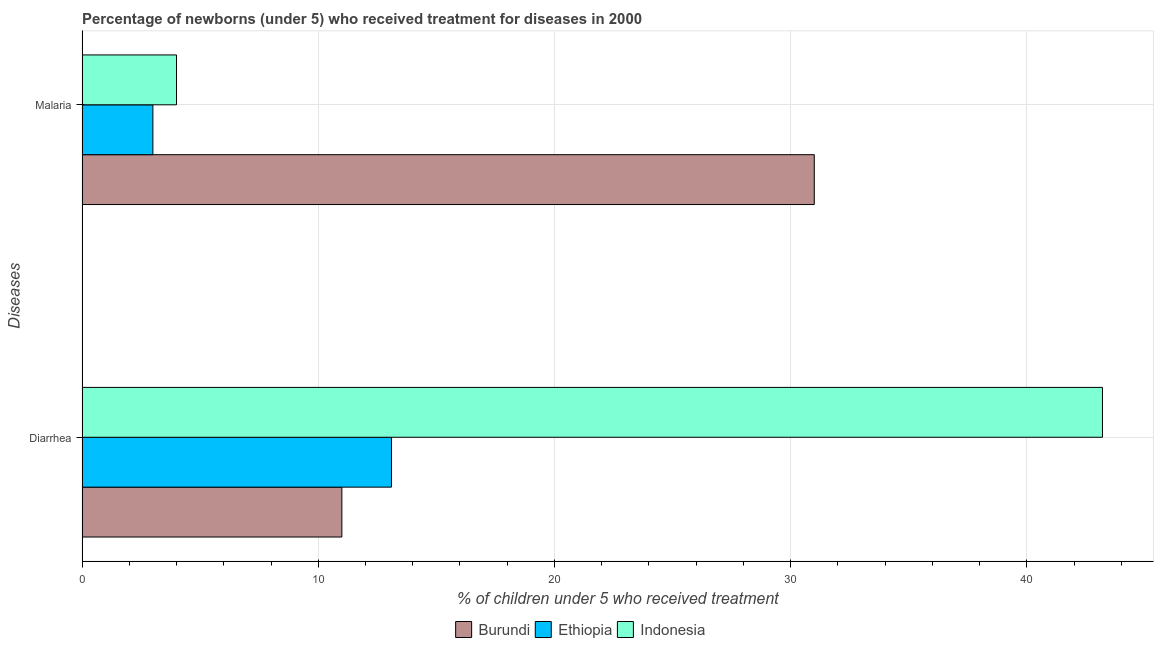How many different coloured bars are there?
Offer a terse response. 3. Are the number of bars per tick equal to the number of legend labels?
Your answer should be very brief. Yes. Are the number of bars on each tick of the Y-axis equal?
Ensure brevity in your answer.  Yes. What is the label of the 2nd group of bars from the top?
Your answer should be compact. Diarrhea. What is the percentage of children who received treatment for malaria in Ethiopia?
Offer a terse response. 3. Across all countries, what is the maximum percentage of children who received treatment for malaria?
Keep it short and to the point. 31. Across all countries, what is the minimum percentage of children who received treatment for diarrhoea?
Keep it short and to the point. 11. In which country was the percentage of children who received treatment for diarrhoea maximum?
Provide a short and direct response. Indonesia. In which country was the percentage of children who received treatment for malaria minimum?
Your response must be concise. Ethiopia. What is the total percentage of children who received treatment for malaria in the graph?
Give a very brief answer. 38. What is the difference between the percentage of children who received treatment for diarrhoea in Ethiopia and that in Burundi?
Keep it short and to the point. 2.1. What is the difference between the percentage of children who received treatment for malaria in Burundi and the percentage of children who received treatment for diarrhoea in Indonesia?
Offer a terse response. -12.2. What is the average percentage of children who received treatment for diarrhoea per country?
Give a very brief answer. 22.43. What is the difference between the percentage of children who received treatment for diarrhoea and percentage of children who received treatment for malaria in Ethiopia?
Your answer should be compact. 10.1. What is the ratio of the percentage of children who received treatment for malaria in Ethiopia to that in Burundi?
Your answer should be compact. 0.1. Is the percentage of children who received treatment for malaria in Ethiopia less than that in Indonesia?
Your answer should be very brief. Yes. What does the 1st bar from the bottom in Diarrhea represents?
Make the answer very short. Burundi. How many countries are there in the graph?
Your answer should be very brief. 3. What is the difference between two consecutive major ticks on the X-axis?
Provide a short and direct response. 10. Does the graph contain grids?
Provide a succinct answer. Yes. Where does the legend appear in the graph?
Provide a short and direct response. Bottom center. How are the legend labels stacked?
Give a very brief answer. Horizontal. What is the title of the graph?
Provide a succinct answer. Percentage of newborns (under 5) who received treatment for diseases in 2000. Does "Kiribati" appear as one of the legend labels in the graph?
Provide a short and direct response. No. What is the label or title of the X-axis?
Keep it short and to the point. % of children under 5 who received treatment. What is the label or title of the Y-axis?
Provide a succinct answer. Diseases. What is the % of children under 5 who received treatment in Ethiopia in Diarrhea?
Keep it short and to the point. 13.1. What is the % of children under 5 who received treatment of Indonesia in Diarrhea?
Your answer should be very brief. 43.2. Across all Diseases, what is the maximum % of children under 5 who received treatment of Ethiopia?
Your answer should be very brief. 13.1. Across all Diseases, what is the maximum % of children under 5 who received treatment of Indonesia?
Your response must be concise. 43.2. Across all Diseases, what is the minimum % of children under 5 who received treatment in Ethiopia?
Make the answer very short. 3. What is the total % of children under 5 who received treatment of Burundi in the graph?
Give a very brief answer. 42. What is the total % of children under 5 who received treatment of Indonesia in the graph?
Your response must be concise. 47.2. What is the difference between the % of children under 5 who received treatment in Burundi in Diarrhea and that in Malaria?
Your answer should be very brief. -20. What is the difference between the % of children under 5 who received treatment in Ethiopia in Diarrhea and that in Malaria?
Offer a terse response. 10.1. What is the difference between the % of children under 5 who received treatment in Indonesia in Diarrhea and that in Malaria?
Your answer should be compact. 39.2. What is the difference between the % of children under 5 who received treatment in Burundi in Diarrhea and the % of children under 5 who received treatment in Indonesia in Malaria?
Make the answer very short. 7. What is the average % of children under 5 who received treatment of Burundi per Diseases?
Ensure brevity in your answer.  21. What is the average % of children under 5 who received treatment in Ethiopia per Diseases?
Offer a terse response. 8.05. What is the average % of children under 5 who received treatment in Indonesia per Diseases?
Provide a succinct answer. 23.6. What is the difference between the % of children under 5 who received treatment in Burundi and % of children under 5 who received treatment in Ethiopia in Diarrhea?
Ensure brevity in your answer.  -2.1. What is the difference between the % of children under 5 who received treatment of Burundi and % of children under 5 who received treatment of Indonesia in Diarrhea?
Provide a short and direct response. -32.2. What is the difference between the % of children under 5 who received treatment of Ethiopia and % of children under 5 who received treatment of Indonesia in Diarrhea?
Give a very brief answer. -30.1. What is the difference between the % of children under 5 who received treatment of Ethiopia and % of children under 5 who received treatment of Indonesia in Malaria?
Offer a very short reply. -1. What is the ratio of the % of children under 5 who received treatment in Burundi in Diarrhea to that in Malaria?
Ensure brevity in your answer.  0.35. What is the ratio of the % of children under 5 who received treatment in Ethiopia in Diarrhea to that in Malaria?
Offer a terse response. 4.37. What is the difference between the highest and the second highest % of children under 5 who received treatment in Burundi?
Make the answer very short. 20. What is the difference between the highest and the second highest % of children under 5 who received treatment of Ethiopia?
Offer a very short reply. 10.1. What is the difference between the highest and the second highest % of children under 5 who received treatment in Indonesia?
Give a very brief answer. 39.2. What is the difference between the highest and the lowest % of children under 5 who received treatment in Ethiopia?
Keep it short and to the point. 10.1. What is the difference between the highest and the lowest % of children under 5 who received treatment of Indonesia?
Keep it short and to the point. 39.2. 